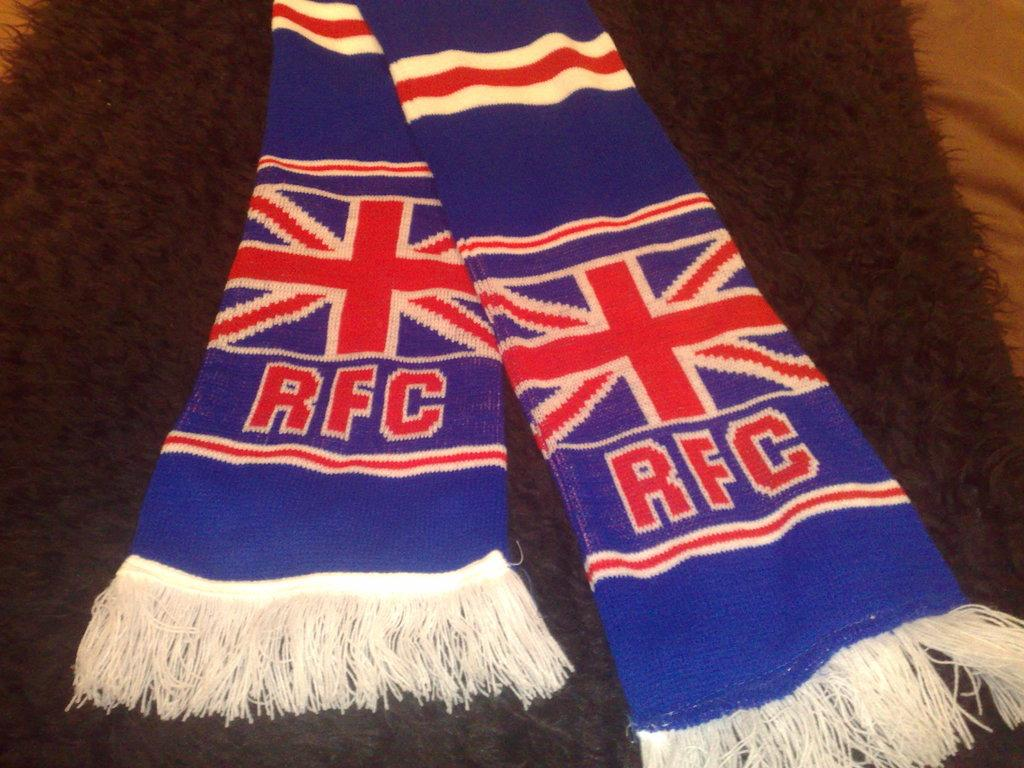<image>
Relay a brief, clear account of the picture shown. A blue scarf has the British flag on it and the letters RFC. 